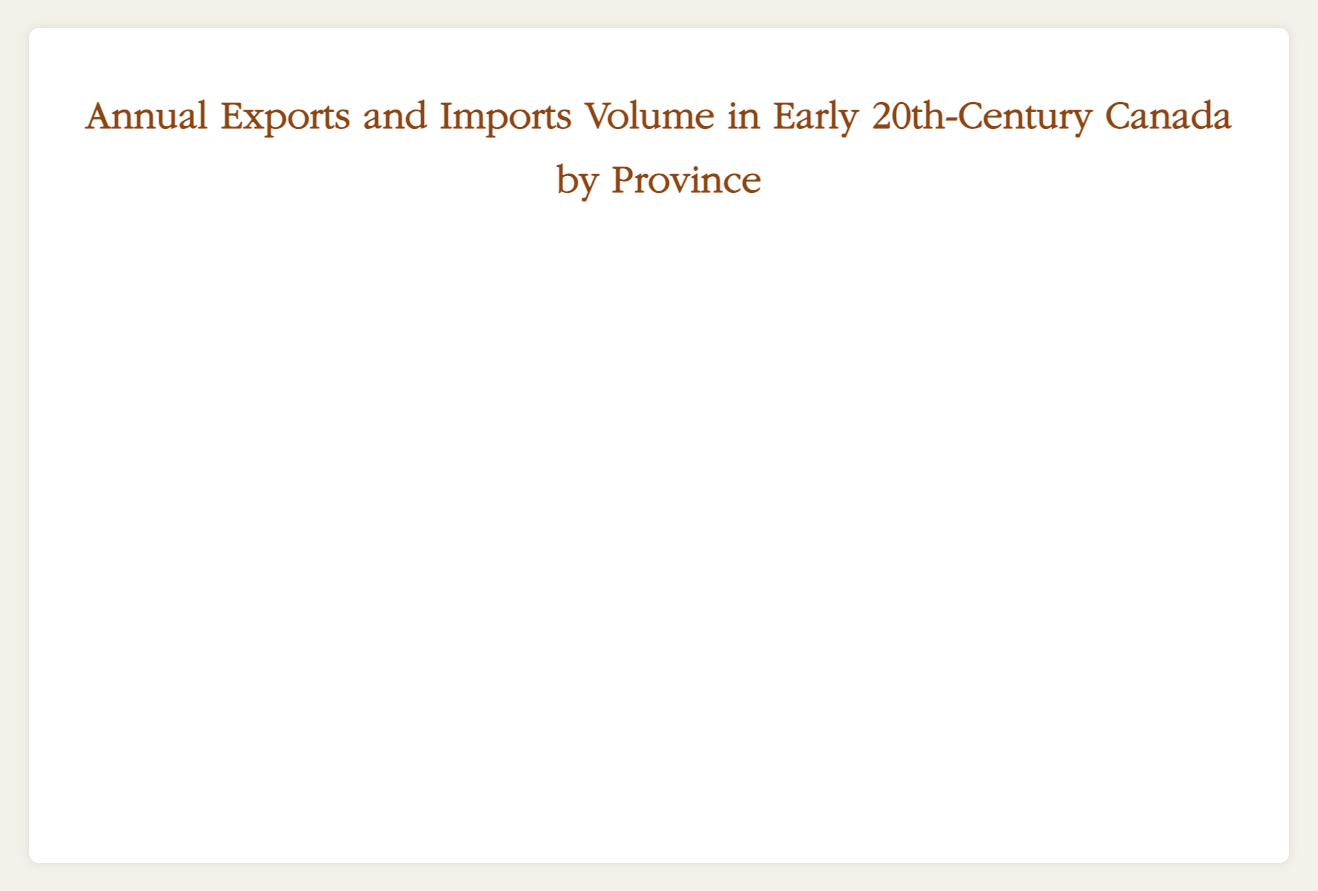What was the overall trade (exports + imports) volume for Ontario in 1920? To find the overall trade volume for Ontario in 1920, sum the exports and imports values for Ontario in that year. The exports for Ontario in 1920 were 7000000, and the imports were 6600000. Summing these values gives 7000000 + 6600000 = 13600000.
Answer: 13600000 Which province saw the highest increase in export volume from 1900 to 1920? Compare the export volumes for each province in 1900 and 1920. For Ontario, the increase was from 5000000 to 7000000, an increase of 2000000. For Quebec, the increase was from 4000000 to 5200000, an increase of 1200000. For British Columbia, the increase was from 3000000 to 4200000, an increase of 1200000. For Alberta, the increase was from 2000000 to 3100000, an increase of 1100000. Ontario had the highest increase of 2000000.
Answer: Ontario Which province had a greater import volume in 1910, Quebec or British Columbia? To compare the import volumes, refer to the values on the chart for 1910. Quebec had an import volume of 4000000, while British Columbia had an import volume of 3000000 in 1910. Since 4000000 is greater than 3000000, Quebec had a greater import volume.
Answer: Quebec How did Alberta's export volume change from 1900 to 1915? Check the export volumes for Alberta in 1900 and 1915. In 1900, the export volume was 2000000. By 1915, it had increased to 2800000. The change is calculated as 2800000 - 2000000 = 800000. Alberta’s export volume increased by 800000 from 1900 to 1915.
Answer: Increased by 800000 Among the provinces, which had the smallest import volume in 1920? Examine the import volumes for the four provinces in 1920. Ontario had 6600000, Quebec had 4600000, British Columbia had 3800000, and Alberta had 2700000. The smallest import volume among these is 2700000, which belongs to Alberta.
Answer: Alberta In which year did British Columbia experience an equal volume of exports and imports? Look for a year where the export and import volumes for British Columbia are equal. In the provided data, the export and import volumes for British Columbia are never equal in any year; either the exports or imports exceed the other. Review each year: the values are distinct in each instance.
Answer: Never Which year shows the greatest difference between import volumes for Ontario and Quebec? Calculate the difference in import volumes for Ontario and Quebec each year: for 1900: 4500000 - 3500000 = 1000000; for 1905: 5000000 - 3700000 = 1300000; for 1910: 5400000 - 4000000 = 1400000; for 1915: 6000000 - 4200000 = 1800000; for 1920: 6600000 - 4600000 = 2000000. The greatest difference occurs in 1920, with a difference of 2000000.
Answer: 1920 